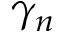Convert formula to latex. <formula><loc_0><loc_0><loc_500><loc_500>\gamma _ { n }</formula> 